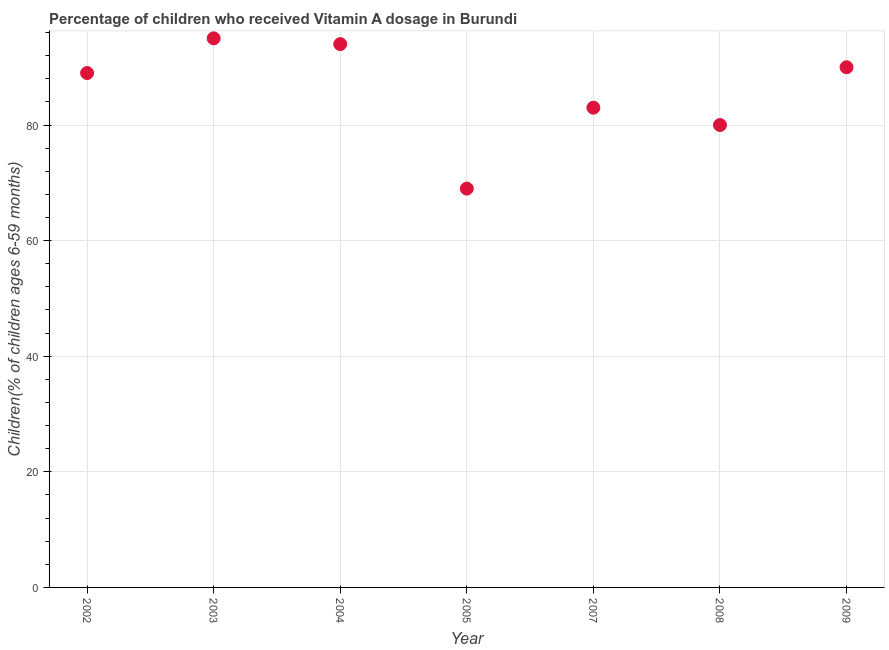What is the vitamin a supplementation coverage rate in 2004?
Make the answer very short. 94. Across all years, what is the minimum vitamin a supplementation coverage rate?
Make the answer very short. 69. In which year was the vitamin a supplementation coverage rate maximum?
Keep it short and to the point. 2003. What is the sum of the vitamin a supplementation coverage rate?
Provide a short and direct response. 600. What is the average vitamin a supplementation coverage rate per year?
Your answer should be compact. 85.71. What is the median vitamin a supplementation coverage rate?
Your answer should be very brief. 89. Do a majority of the years between 2005 and 2004 (inclusive) have vitamin a supplementation coverage rate greater than 4 %?
Your response must be concise. No. What is the ratio of the vitamin a supplementation coverage rate in 2003 to that in 2004?
Your answer should be very brief. 1.01. Is the vitamin a supplementation coverage rate in 2003 less than that in 2007?
Your answer should be very brief. No. How many dotlines are there?
Your response must be concise. 1. What is the difference between two consecutive major ticks on the Y-axis?
Offer a terse response. 20. Are the values on the major ticks of Y-axis written in scientific E-notation?
Offer a very short reply. No. Does the graph contain grids?
Offer a terse response. Yes. What is the title of the graph?
Provide a succinct answer. Percentage of children who received Vitamin A dosage in Burundi. What is the label or title of the X-axis?
Your answer should be very brief. Year. What is the label or title of the Y-axis?
Keep it short and to the point. Children(% of children ages 6-59 months). What is the Children(% of children ages 6-59 months) in 2002?
Provide a short and direct response. 89. What is the Children(% of children ages 6-59 months) in 2003?
Provide a short and direct response. 95. What is the Children(% of children ages 6-59 months) in 2004?
Your answer should be compact. 94. What is the Children(% of children ages 6-59 months) in 2008?
Your response must be concise. 80. What is the difference between the Children(% of children ages 6-59 months) in 2002 and 2003?
Give a very brief answer. -6. What is the difference between the Children(% of children ages 6-59 months) in 2002 and 2005?
Ensure brevity in your answer.  20. What is the difference between the Children(% of children ages 6-59 months) in 2002 and 2009?
Provide a succinct answer. -1. What is the difference between the Children(% of children ages 6-59 months) in 2003 and 2005?
Give a very brief answer. 26. What is the difference between the Children(% of children ages 6-59 months) in 2004 and 2007?
Give a very brief answer. 11. What is the difference between the Children(% of children ages 6-59 months) in 2007 and 2009?
Your answer should be very brief. -7. What is the difference between the Children(% of children ages 6-59 months) in 2008 and 2009?
Offer a terse response. -10. What is the ratio of the Children(% of children ages 6-59 months) in 2002 to that in 2003?
Give a very brief answer. 0.94. What is the ratio of the Children(% of children ages 6-59 months) in 2002 to that in 2004?
Ensure brevity in your answer.  0.95. What is the ratio of the Children(% of children ages 6-59 months) in 2002 to that in 2005?
Give a very brief answer. 1.29. What is the ratio of the Children(% of children ages 6-59 months) in 2002 to that in 2007?
Provide a succinct answer. 1.07. What is the ratio of the Children(% of children ages 6-59 months) in 2002 to that in 2008?
Provide a short and direct response. 1.11. What is the ratio of the Children(% of children ages 6-59 months) in 2003 to that in 2004?
Offer a terse response. 1.01. What is the ratio of the Children(% of children ages 6-59 months) in 2003 to that in 2005?
Ensure brevity in your answer.  1.38. What is the ratio of the Children(% of children ages 6-59 months) in 2003 to that in 2007?
Provide a succinct answer. 1.15. What is the ratio of the Children(% of children ages 6-59 months) in 2003 to that in 2008?
Provide a succinct answer. 1.19. What is the ratio of the Children(% of children ages 6-59 months) in 2003 to that in 2009?
Your answer should be compact. 1.06. What is the ratio of the Children(% of children ages 6-59 months) in 2004 to that in 2005?
Offer a very short reply. 1.36. What is the ratio of the Children(% of children ages 6-59 months) in 2004 to that in 2007?
Your response must be concise. 1.13. What is the ratio of the Children(% of children ages 6-59 months) in 2004 to that in 2008?
Offer a terse response. 1.18. What is the ratio of the Children(% of children ages 6-59 months) in 2004 to that in 2009?
Offer a very short reply. 1.04. What is the ratio of the Children(% of children ages 6-59 months) in 2005 to that in 2007?
Provide a short and direct response. 0.83. What is the ratio of the Children(% of children ages 6-59 months) in 2005 to that in 2008?
Your answer should be very brief. 0.86. What is the ratio of the Children(% of children ages 6-59 months) in 2005 to that in 2009?
Keep it short and to the point. 0.77. What is the ratio of the Children(% of children ages 6-59 months) in 2007 to that in 2008?
Your answer should be compact. 1.04. What is the ratio of the Children(% of children ages 6-59 months) in 2007 to that in 2009?
Offer a terse response. 0.92. What is the ratio of the Children(% of children ages 6-59 months) in 2008 to that in 2009?
Give a very brief answer. 0.89. 